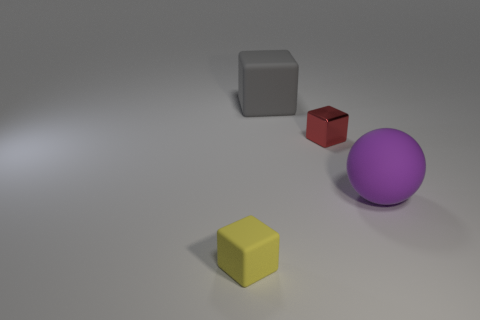Is the tiny shiny cube the same color as the rubber sphere?
Provide a short and direct response. No. What is the shape of the tiny thing that is behind the small yellow cube?
Provide a short and direct response. Cube. Is the number of matte cubes that are behind the large gray matte thing less than the number of large rubber spheres that are behind the purple matte sphere?
Make the answer very short. No. Does the block behind the metallic object have the same material as the small cube behind the yellow object?
Your answer should be compact. No. What shape is the purple thing?
Offer a terse response. Sphere. Is the number of small yellow matte blocks left of the small yellow object greater than the number of gray rubber objects right of the ball?
Offer a very short reply. No. Does the large thing that is in front of the tiny metal object have the same shape as the thing in front of the big purple sphere?
Keep it short and to the point. No. How many other things are there of the same size as the gray thing?
Offer a very short reply. 1. How big is the yellow block?
Give a very brief answer. Small. Are the large cube that is behind the tiny metallic cube and the red block made of the same material?
Ensure brevity in your answer.  No. 